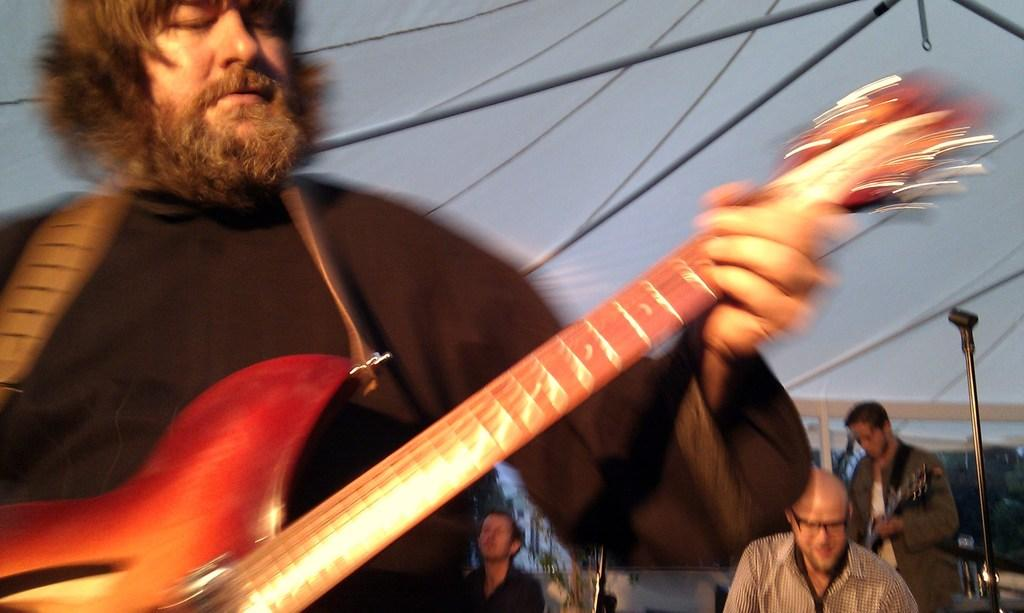What is the person in the image wearing? The person is wearing a black dress in the image. What is the person holding? The person is holding a guitar in the image. What is the person doing with the guitar? The person is playing the guitar in the image. What type of structure can be seen in the background? It appears to be a tent in the image. Are there any other people in the image? Yes, there are other people behind the person. What are these people doing? These people are playing musical instruments in the image. What is the purpose of the microphone stand in the image? The microphone stand is likely used for amplifying the sound of the musical instruments. What type of school does the fireman attend in the image? There is no fireman or school present in the image; it features a person playing a guitar and other people playing musical instruments in a tent. 